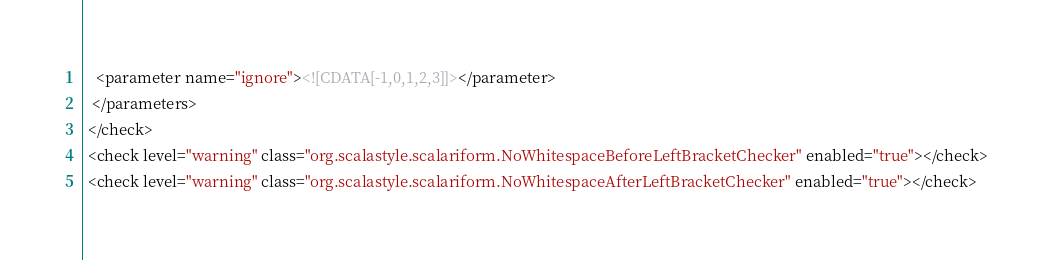Convert code to text. <code><loc_0><loc_0><loc_500><loc_500><_XML_>   <parameter name="ignore"><![CDATA[-1,0,1,2,3]]></parameter>
  </parameters>
 </check>
 <check level="warning" class="org.scalastyle.scalariform.NoWhitespaceBeforeLeftBracketChecker" enabled="true"></check>
 <check level="warning" class="org.scalastyle.scalariform.NoWhitespaceAfterLeftBracketChecker" enabled="true"></check></code> 